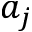Convert formula to latex. <formula><loc_0><loc_0><loc_500><loc_500>a _ { j }</formula> 